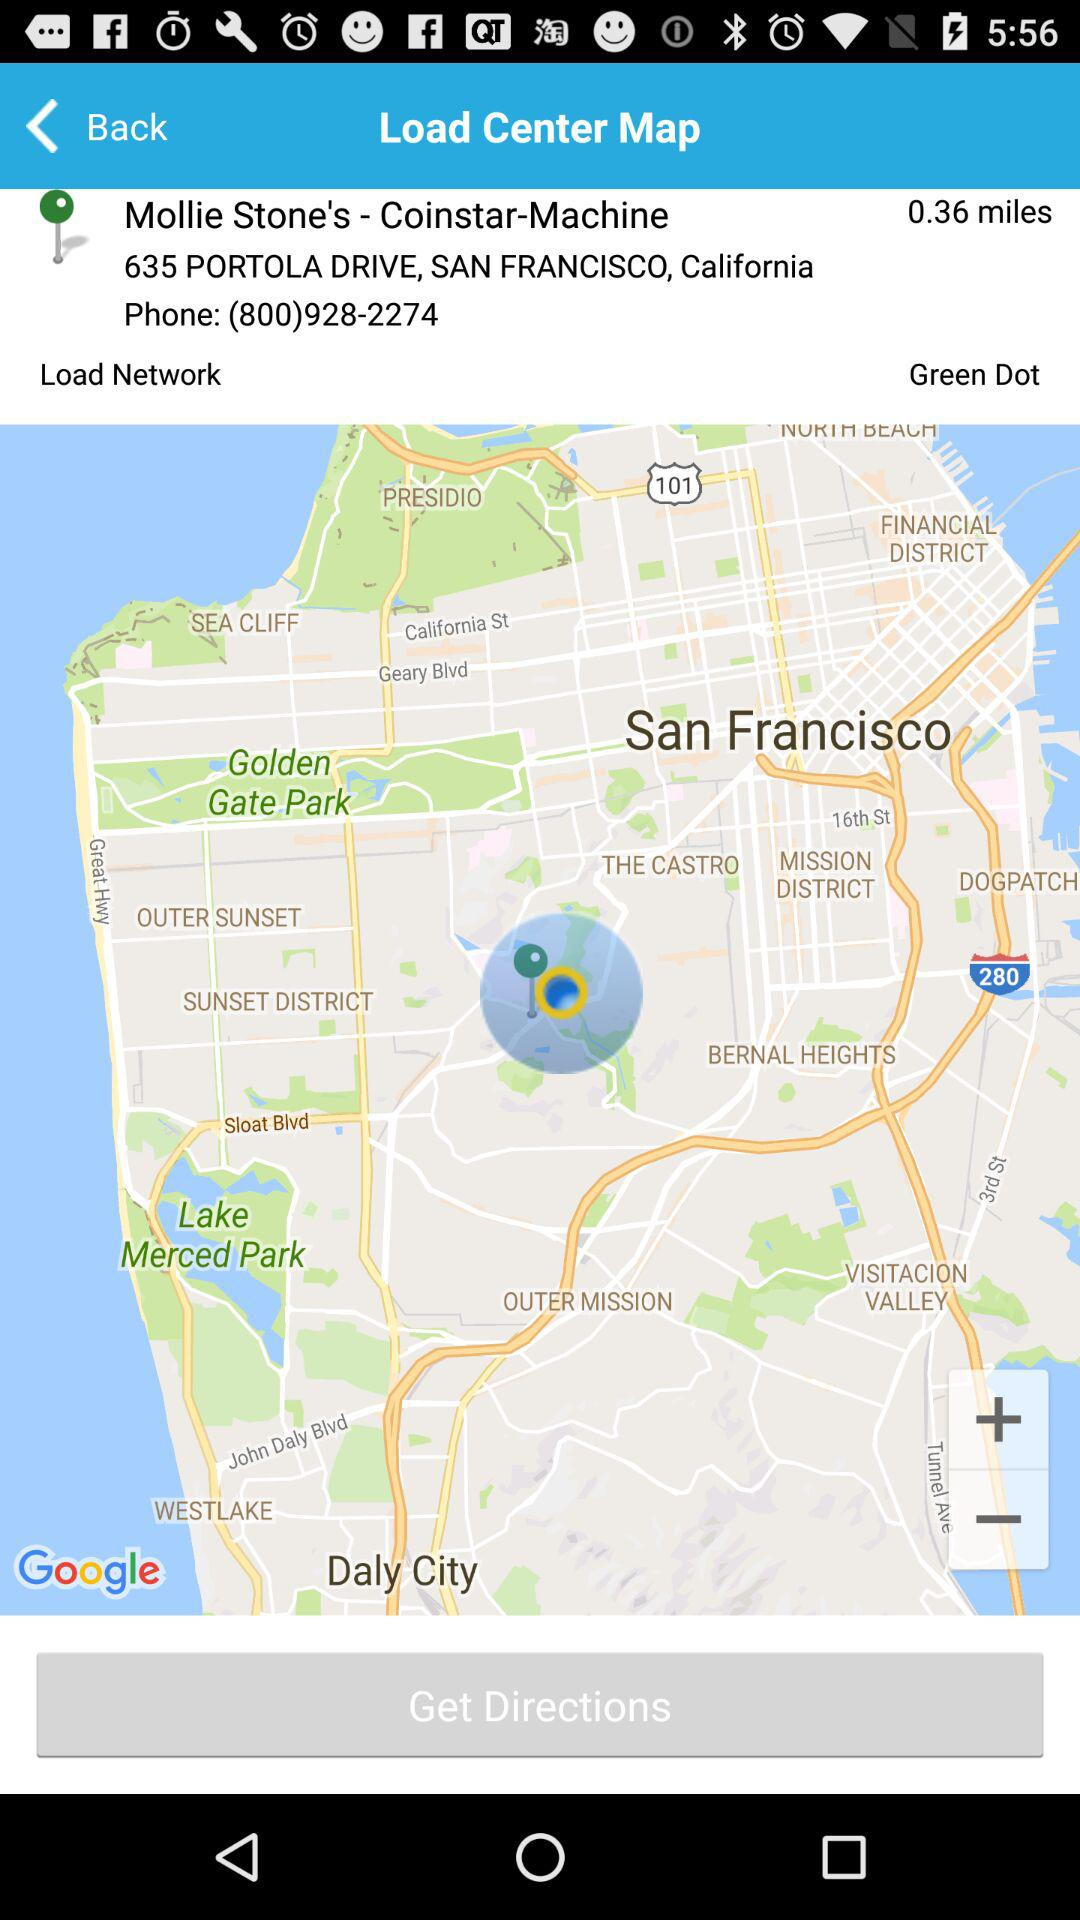What is the pinned location? The pinned location is 635 Portola Drive, San Francisco, California. 